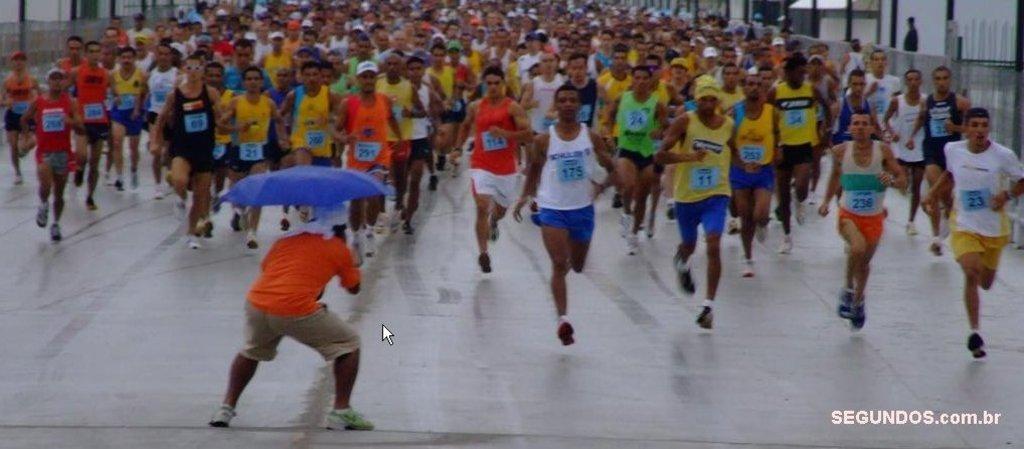Describe this image in one or two sentences. In this picture, we see many people running on the road. At the bottom of the picture, the man in orange T-shirt is holding a blue color umbrella in his hands. On either side of the picture, we see buildings. This picture might be clicked outside the city. 